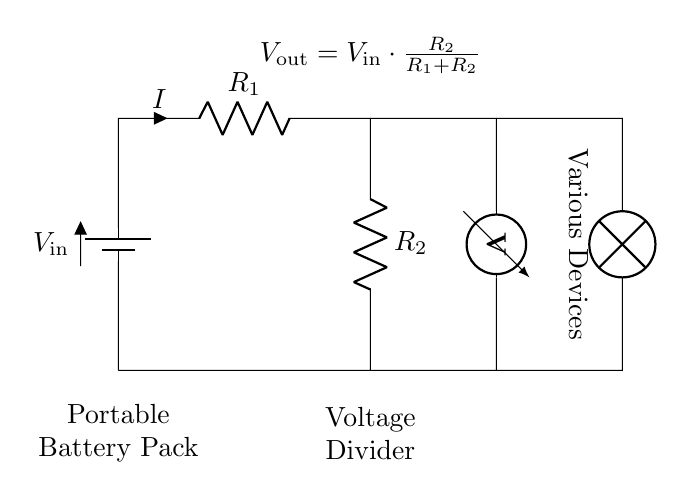What is the input voltage of the circuit? The input voltage is represented by the symbol V in the circuit, indicating the potential difference supplied to the circuit, which is shown on the battery.
Answer: V_in What are the two resistors in the voltage divider? The resistors are labeled as R_1 and R_2 in the circuit diagram, which are necessary for creating the voltage division effect.
Answer: R_1 and R_2 What will you connect to the output from the voltage divider? The output voltage is taken from the junction between R_1 and R_2 and is used to power various devices, as indicated in the diagram.
Answer: Various Devices What determines the output voltage of the voltage divider? The output voltage (V_out) is calculated using the equation shown, which depends on V_in and the resistance values of R_1 and R_2.
Answer: V_in and R_1, R_2 What is the formula for the output voltage in this circuit? The output voltage is derived from the voltage divider formula displayed in the circuit diagram, specifically V_out = V_in * (R_2 / (R_1 + R_2)).
Answer: V_out = V_in * (R_2 / (R_1 + R_2)) How does increasing R_2 affect V_out? Increasing R_2 increases the proportion of V_in that is dropped across R_2, thus increasing V_out according to the voltage divider rule.
Answer: Increases V_out What type of circuit is this? This is categorized as a voltage divider circuit, which is a specific configuration to reduce voltage for different applications.
Answer: Voltage Divider 